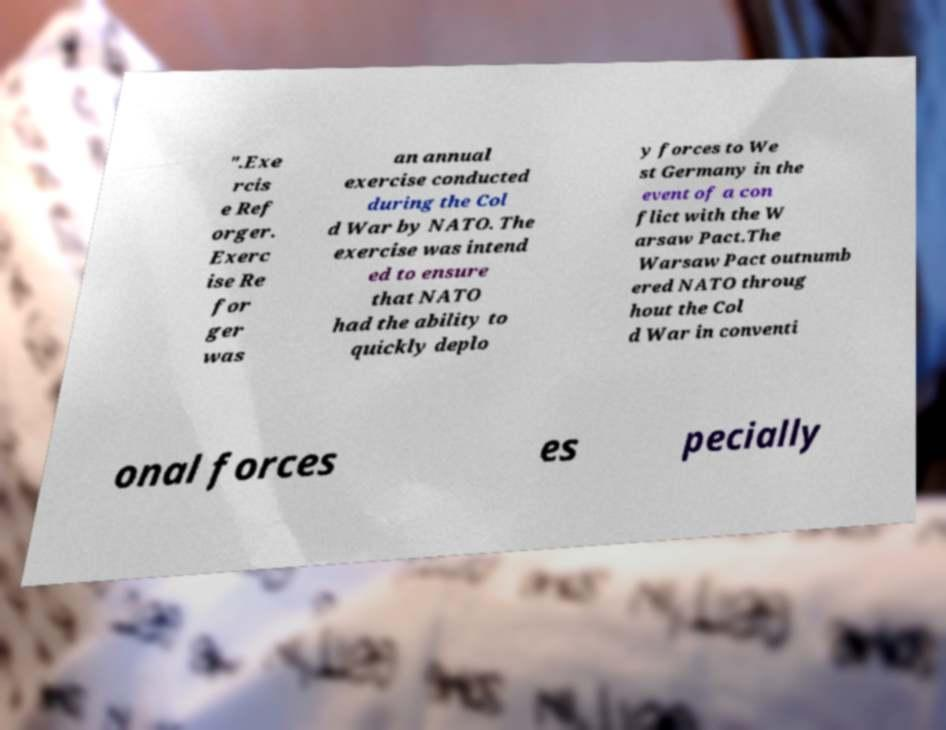Can you accurately transcribe the text from the provided image for me? ".Exe rcis e Ref orger. Exerc ise Re for ger was an annual exercise conducted during the Col d War by NATO. The exercise was intend ed to ensure that NATO had the ability to quickly deplo y forces to We st Germany in the event of a con flict with the W arsaw Pact.The Warsaw Pact outnumb ered NATO throug hout the Col d War in conventi onal forces es pecially 